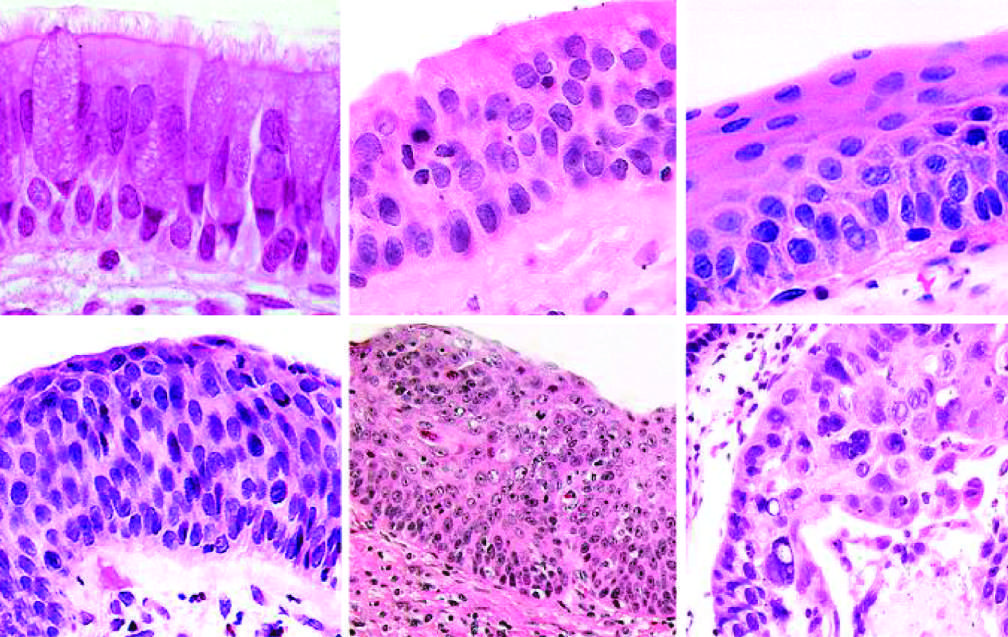what is the stage that immediately precedes invasive squamous cell carcinoma?
Answer the question using a single word or phrase. Carcinoma in situ (cis) 